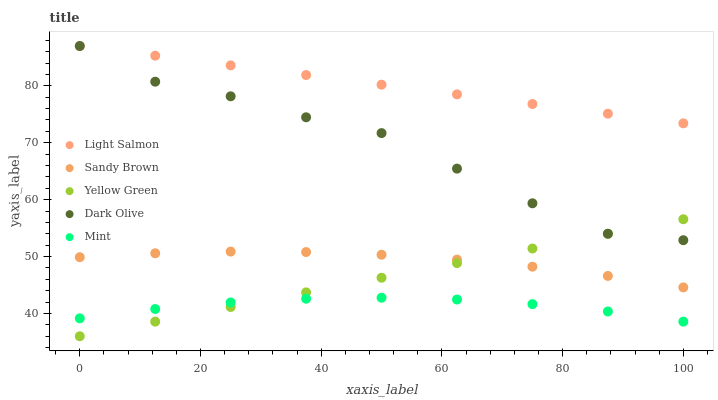Does Mint have the minimum area under the curve?
Answer yes or no. Yes. Does Light Salmon have the maximum area under the curve?
Answer yes or no. Yes. Does Dark Olive have the minimum area under the curve?
Answer yes or no. No. Does Dark Olive have the maximum area under the curve?
Answer yes or no. No. Is Yellow Green the smoothest?
Answer yes or no. Yes. Is Dark Olive the roughest?
Answer yes or no. Yes. Is Light Salmon the smoothest?
Answer yes or no. No. Is Light Salmon the roughest?
Answer yes or no. No. Does Yellow Green have the lowest value?
Answer yes or no. Yes. Does Dark Olive have the lowest value?
Answer yes or no. No. Does Dark Olive have the highest value?
Answer yes or no. Yes. Does Sandy Brown have the highest value?
Answer yes or no. No. Is Sandy Brown less than Light Salmon?
Answer yes or no. Yes. Is Light Salmon greater than Yellow Green?
Answer yes or no. Yes. Does Mint intersect Yellow Green?
Answer yes or no. Yes. Is Mint less than Yellow Green?
Answer yes or no. No. Is Mint greater than Yellow Green?
Answer yes or no. No. Does Sandy Brown intersect Light Salmon?
Answer yes or no. No. 